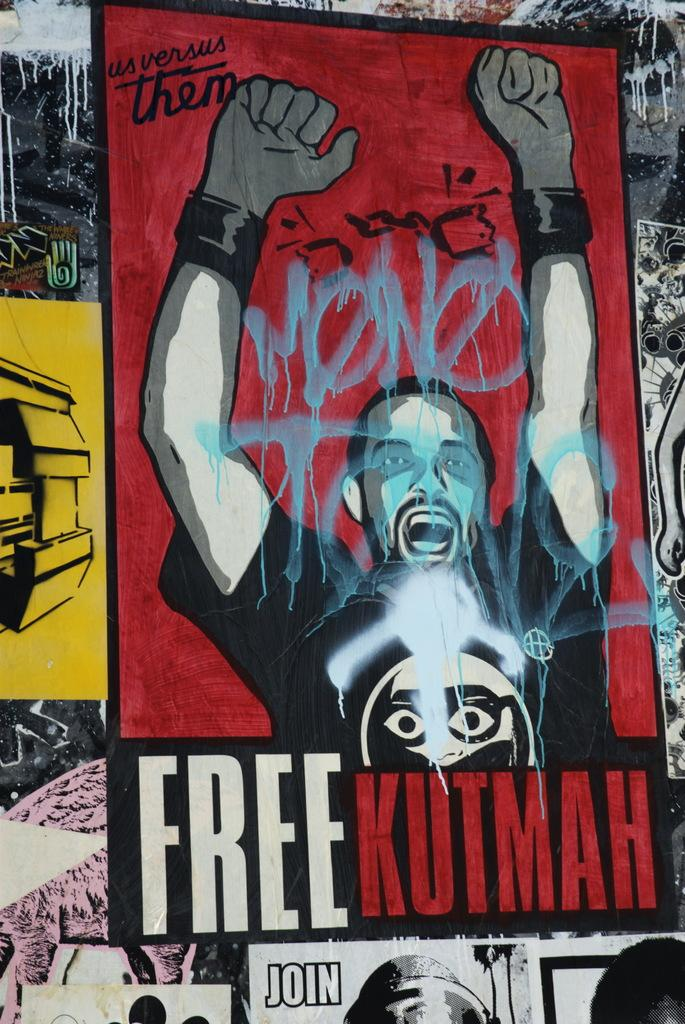What objects can be seen in the image that are used for support or structure? There are posts in the image that are used for support or structure. What type of printed material is visible in the image? There is a poster in the image. What is depicted on the poster? The poster contains a person. What else is featured on the poster besides the person? The poster contains text. What direction is the church facing in the image? There is no church present in the image. How many legs does the person on the poster have? The person on the poster is a two-dimensional image and does not have legs. 